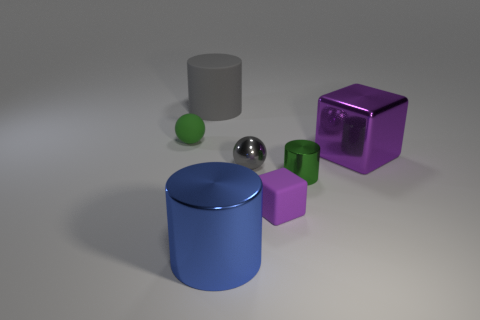Add 2 large gray rubber things. How many objects exist? 9 Subtract all cylinders. How many objects are left? 4 Add 3 big blue objects. How many big blue objects are left? 4 Add 2 green cylinders. How many green cylinders exist? 3 Subtract 0 red cubes. How many objects are left? 7 Subtract all small gray objects. Subtract all big purple metal blocks. How many objects are left? 5 